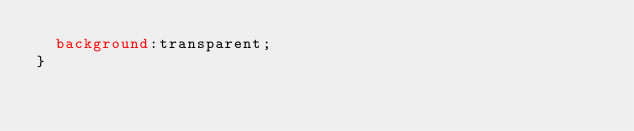<code> <loc_0><loc_0><loc_500><loc_500><_CSS_>  background:transparent;
}</code> 